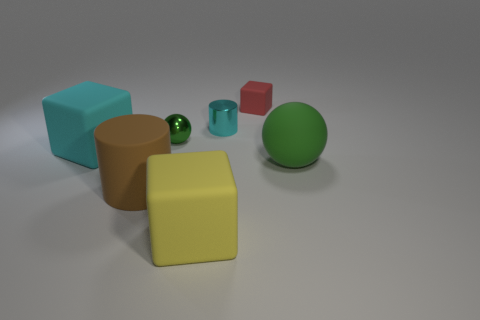What color is the other shiny thing that is the same shape as the brown thing? The shiny object sharing the same cylindrical shape as the brown thing is teal, reflecting light and giving a glossy appearance indicative of a smooth, possibly metallic surface. 